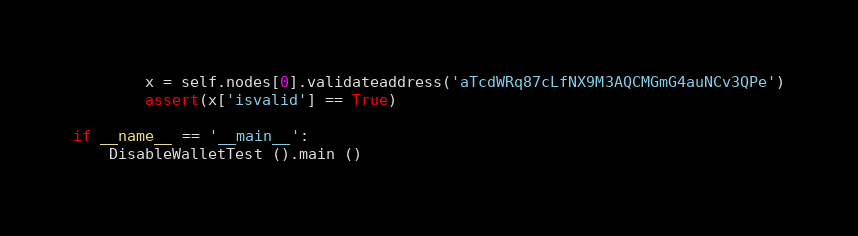Convert code to text. <code><loc_0><loc_0><loc_500><loc_500><_Python_>        x = self.nodes[0].validateaddress('aTcdWRq87cLfNX9M3AQCMGmG4auNCv3QPe')
        assert(x['isvalid'] == True)

if __name__ == '__main__':
    DisableWalletTest ().main ()
</code> 